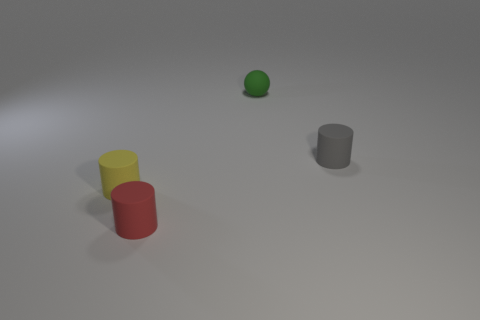Is the shape of the small object that is right of the matte sphere the same as the small rubber thing that is to the left of the red thing?
Your answer should be very brief. Yes. Are there any green things?
Make the answer very short. Yes. The matte ball that is the same size as the yellow rubber cylinder is what color?
Give a very brief answer. Green. Are the tiny yellow object and the tiny red object made of the same material?
Make the answer very short. Yes. How many other small spheres are the same color as the tiny rubber sphere?
Ensure brevity in your answer.  0. There is a tiny cylinder that is on the right side of the red cylinder; what is it made of?
Ensure brevity in your answer.  Rubber. How many small objects are red matte blocks or green balls?
Ensure brevity in your answer.  1. Is there a green ball that has the same material as the tiny yellow cylinder?
Give a very brief answer. Yes. Does the object that is on the right side of the green rubber sphere have the same size as the green rubber ball?
Make the answer very short. Yes. Are there any yellow things to the right of the cylinder to the right of the rubber thing that is behind the gray object?
Offer a terse response. No. 